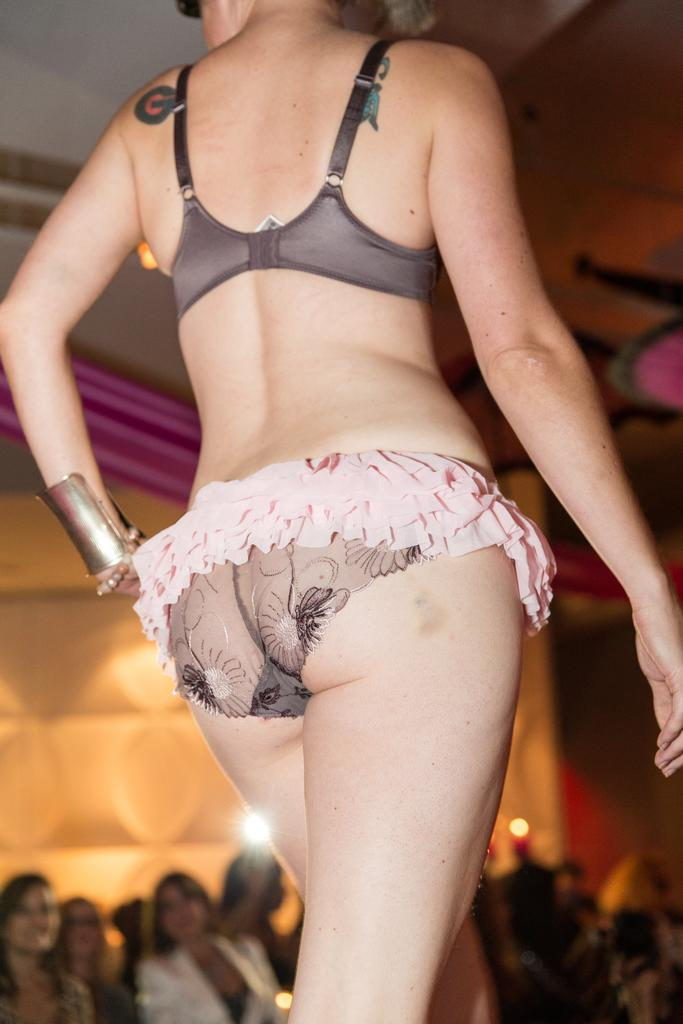What is the woman in the image wearing? There is a woman in a bikini in the image. What is the woman doing in the image? The woman is walking on a stage. What can be seen in the background of the image? There are persons sitting on chairs, a light, a roof, and a wall visible in the background. What type of bread is being served to the audience in the image? There is no bread present in the image. What kind of beef dish is being prepared backstage in the image? There is no beef dish or any food preparation visible in the image. 